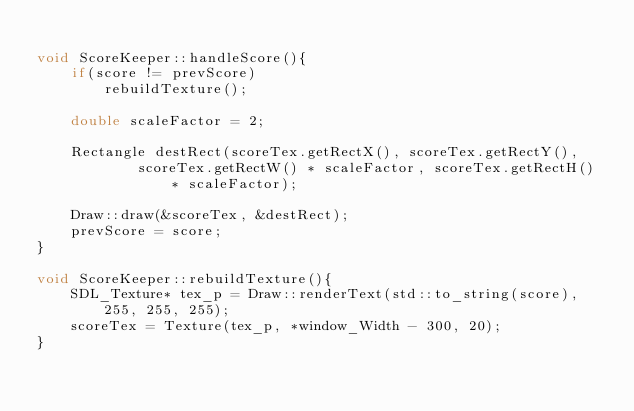<code> <loc_0><loc_0><loc_500><loc_500><_C++_>
void ScoreKeeper::handleScore(){
    if(score != prevScore)
        rebuildTexture();

    double scaleFactor = 2;

    Rectangle destRect(scoreTex.getRectX(), scoreTex.getRectY(),
            scoreTex.getRectW() * scaleFactor, scoreTex.getRectH() * scaleFactor);

    Draw::draw(&scoreTex, &destRect);
    prevScore = score;
}

void ScoreKeeper::rebuildTexture(){
    SDL_Texture* tex_p = Draw::renderText(std::to_string(score), 255, 255, 255);
    scoreTex = Texture(tex_p, *window_Width - 300, 20);
}
</code> 